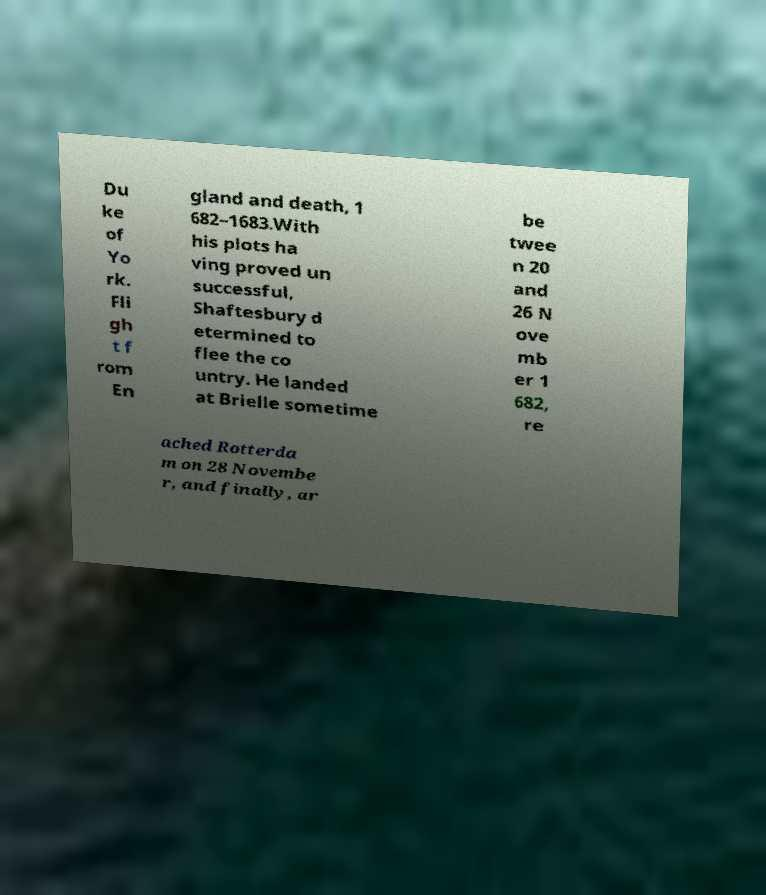Please read and relay the text visible in this image. What does it say? Du ke of Yo rk. Fli gh t f rom En gland and death, 1 682–1683.With his plots ha ving proved un successful, Shaftesbury d etermined to flee the co untry. He landed at Brielle sometime be twee n 20 and 26 N ove mb er 1 682, re ached Rotterda m on 28 Novembe r, and finally, ar 